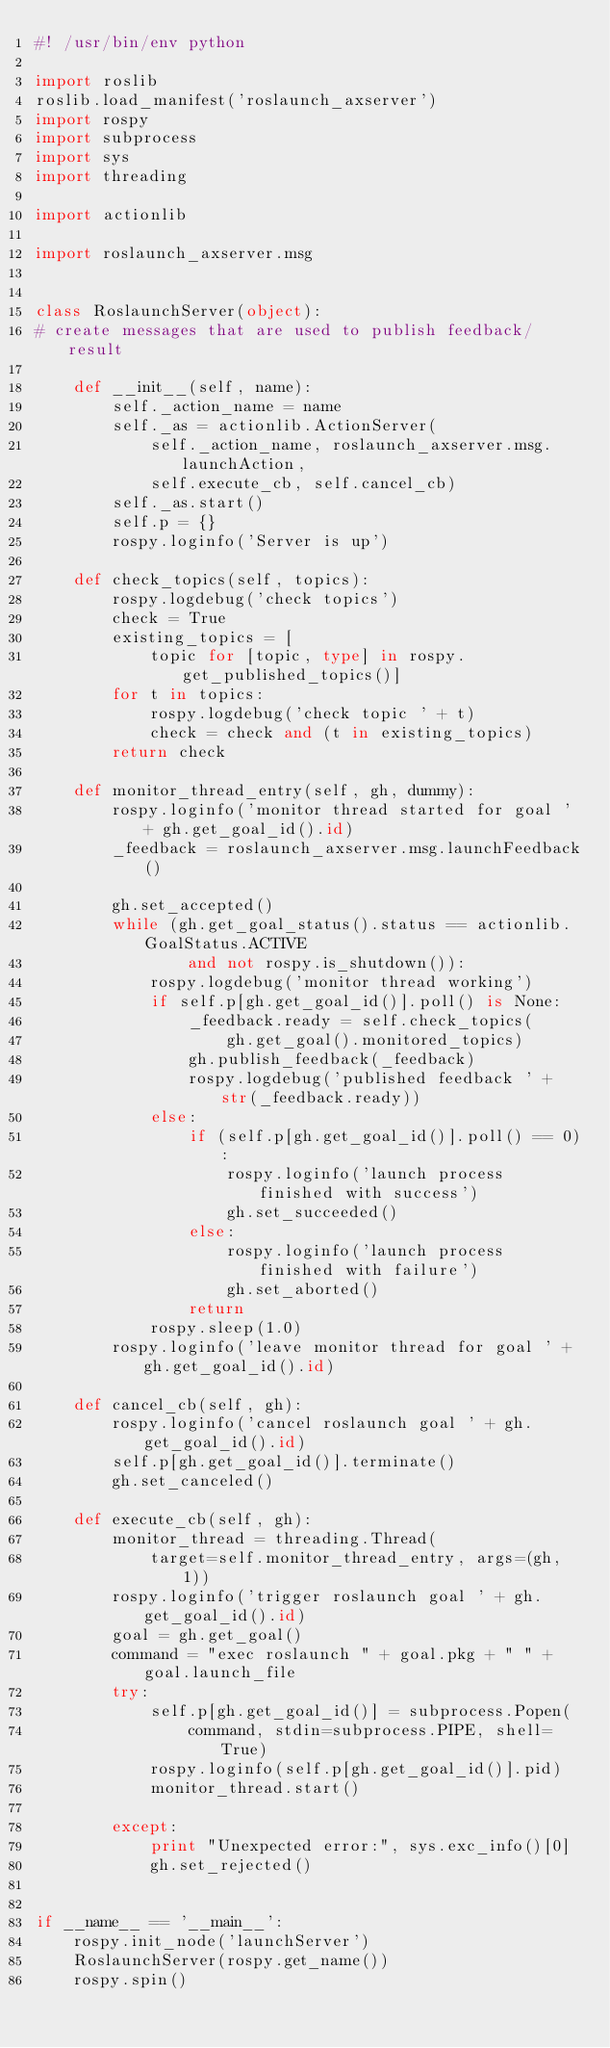Convert code to text. <code><loc_0><loc_0><loc_500><loc_500><_Python_>#! /usr/bin/env python

import roslib
roslib.load_manifest('roslaunch_axserver')
import rospy
import subprocess
import sys
import threading

import actionlib

import roslaunch_axserver.msg


class RoslaunchServer(object):
# create messages that are used to publish feedback/result

    def __init__(self, name):
        self._action_name = name
        self._as = actionlib.ActionServer(
            self._action_name, roslaunch_axserver.msg.launchAction,
            self.execute_cb, self.cancel_cb)
        self._as.start()
        self.p = {}
        rospy.loginfo('Server is up')

    def check_topics(self, topics):
        rospy.logdebug('check topics')
        check = True
        existing_topics = [
            topic for [topic, type] in rospy.get_published_topics()]
        for t in topics:
            rospy.logdebug('check topic ' + t)
            check = check and (t in existing_topics)
        return check

    def monitor_thread_entry(self, gh, dummy):
        rospy.loginfo('monitor thread started for goal ' + gh.get_goal_id().id)
        _feedback = roslaunch_axserver.msg.launchFeedback()

        gh.set_accepted()
        while (gh.get_goal_status().status == actionlib.GoalStatus.ACTIVE
                and not rospy.is_shutdown()):
            rospy.logdebug('monitor thread working')
            if self.p[gh.get_goal_id()].poll() is None:
                _feedback.ready = self.check_topics(
                    gh.get_goal().monitored_topics)
                gh.publish_feedback(_feedback)
                rospy.logdebug('published feedback ' + str(_feedback.ready))
            else:
                if (self.p[gh.get_goal_id()].poll() == 0):
                    rospy.loginfo('launch process finished with success')
                    gh.set_succeeded()
                else:
                    rospy.loginfo('launch process finished with failure')
                    gh.set_aborted()
                return
            rospy.sleep(1.0)
        rospy.loginfo('leave monitor thread for goal ' + gh.get_goal_id().id)

    def cancel_cb(self, gh):
        rospy.loginfo('cancel roslaunch goal ' + gh.get_goal_id().id)
        self.p[gh.get_goal_id()].terminate()
        gh.set_canceled()

    def execute_cb(self, gh):
        monitor_thread = threading.Thread(
            target=self.monitor_thread_entry, args=(gh, 1))
        rospy.loginfo('trigger roslaunch goal ' + gh.get_goal_id().id)
        goal = gh.get_goal()
        command = "exec roslaunch " + goal.pkg + " " + goal.launch_file
        try:
            self.p[gh.get_goal_id()] = subprocess.Popen(
                command, stdin=subprocess.PIPE, shell=True)
            rospy.loginfo(self.p[gh.get_goal_id()].pid)
            monitor_thread.start()

        except:
            print "Unexpected error:", sys.exc_info()[0]
            gh.set_rejected()


if __name__ == '__main__':
    rospy.init_node('launchServer')
    RoslaunchServer(rospy.get_name())
    rospy.spin()
</code> 